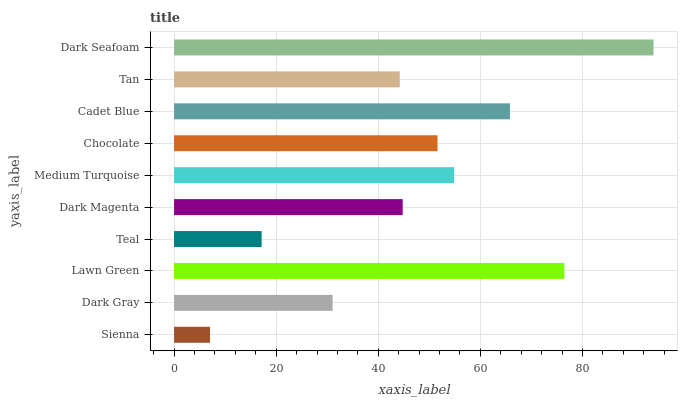Is Sienna the minimum?
Answer yes or no. Yes. Is Dark Seafoam the maximum?
Answer yes or no. Yes. Is Dark Gray the minimum?
Answer yes or no. No. Is Dark Gray the maximum?
Answer yes or no. No. Is Dark Gray greater than Sienna?
Answer yes or no. Yes. Is Sienna less than Dark Gray?
Answer yes or no. Yes. Is Sienna greater than Dark Gray?
Answer yes or no. No. Is Dark Gray less than Sienna?
Answer yes or no. No. Is Chocolate the high median?
Answer yes or no. Yes. Is Dark Magenta the low median?
Answer yes or no. Yes. Is Medium Turquoise the high median?
Answer yes or no. No. Is Dark Seafoam the low median?
Answer yes or no. No. 